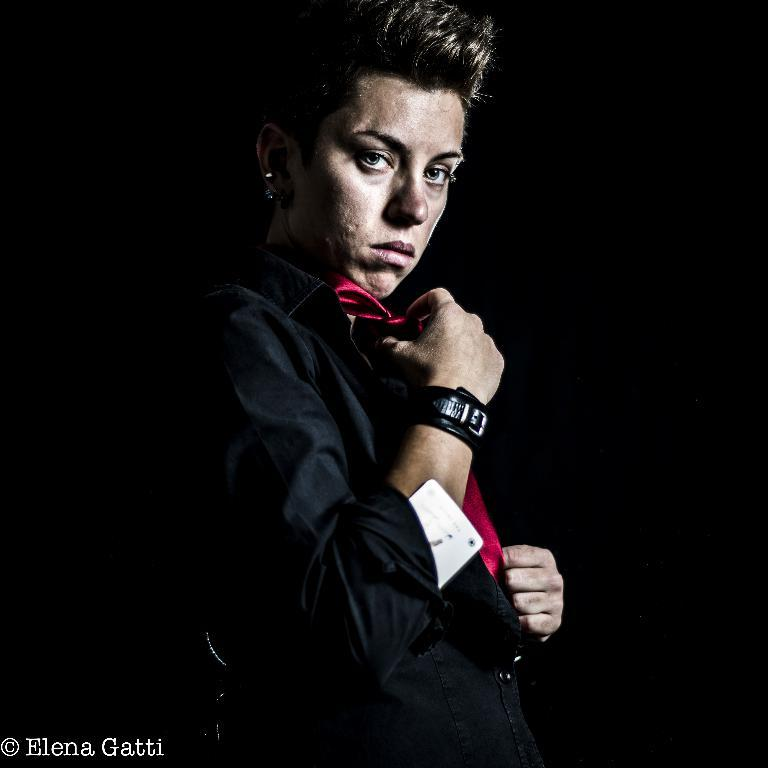Who is the main subject in the image? There is a woman in the image. What is the woman wearing? The woman is wearing a black dress. Are there any accessories visible on the woman? Yes, the woman is wearing a watch. What can be seen in the background of the image? The background of the image is dark. What type of tub is visible in the image? There is no tub present in the image. Is the woman holding a bunch of celery in the image? No, the woman is not holding any celery in the image. 